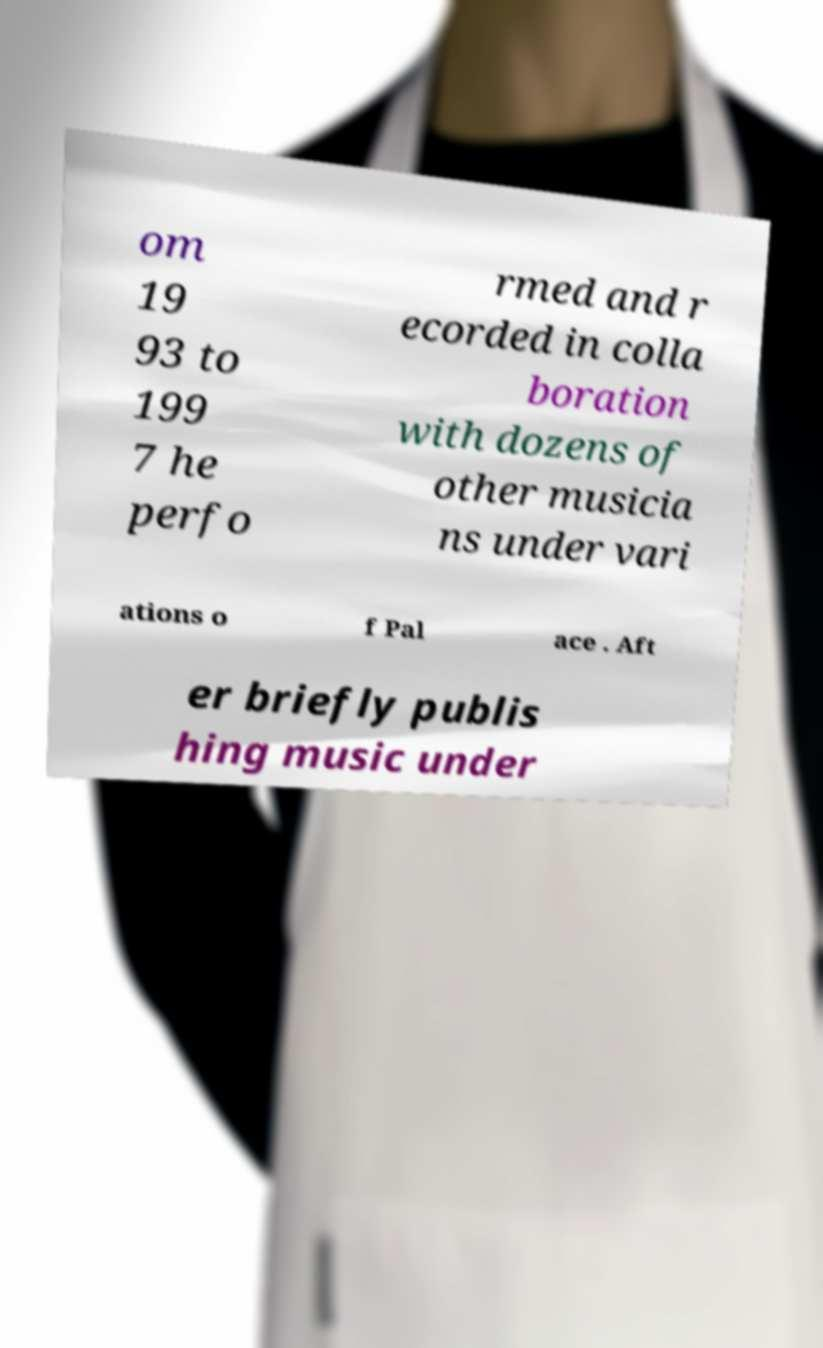What messages or text are displayed in this image? I need them in a readable, typed format. om 19 93 to 199 7 he perfo rmed and r ecorded in colla boration with dozens of other musicia ns under vari ations o f Pal ace . Aft er briefly publis hing music under 